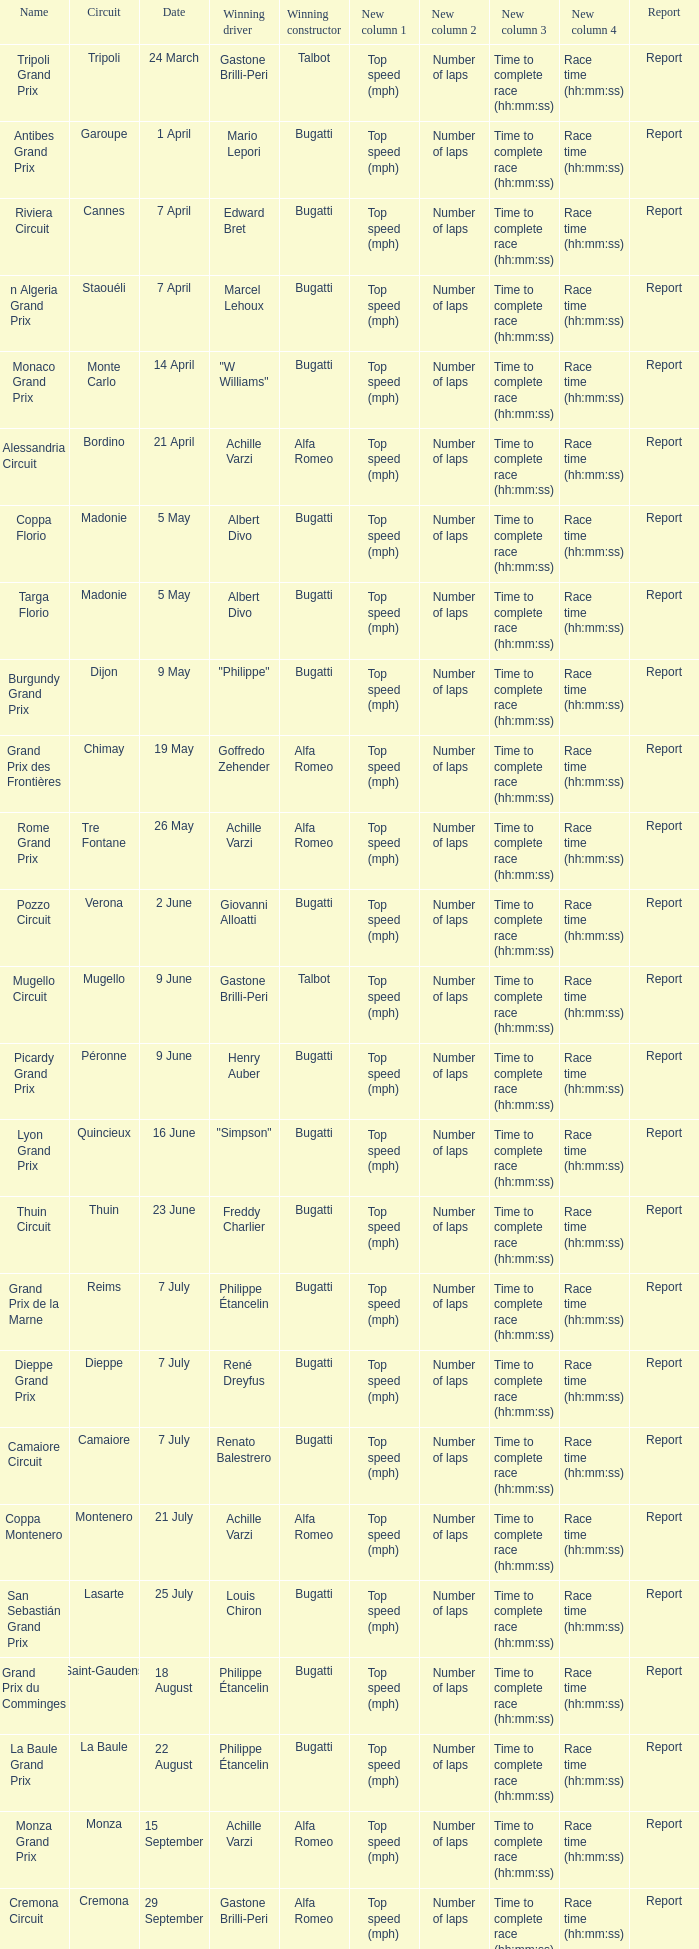What Winning driver has a Winning constructor of talbot? Gastone Brilli-Peri, Gastone Brilli-Peri. 